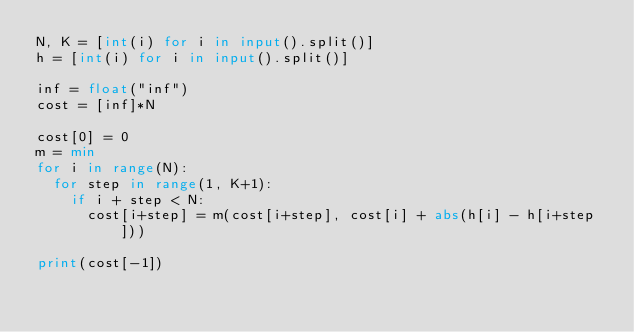<code> <loc_0><loc_0><loc_500><loc_500><_Python_>N, K = [int(i) for i in input().split()]
h = [int(i) for i in input().split()]

inf = float("inf")
cost = [inf]*N

cost[0] = 0
m = min
for i in range(N):
  for step in range(1, K+1):
    if i + step < N:
      cost[i+step] = m(cost[i+step], cost[i] + abs(h[i] - h[i+step]))

print(cost[-1])</code> 